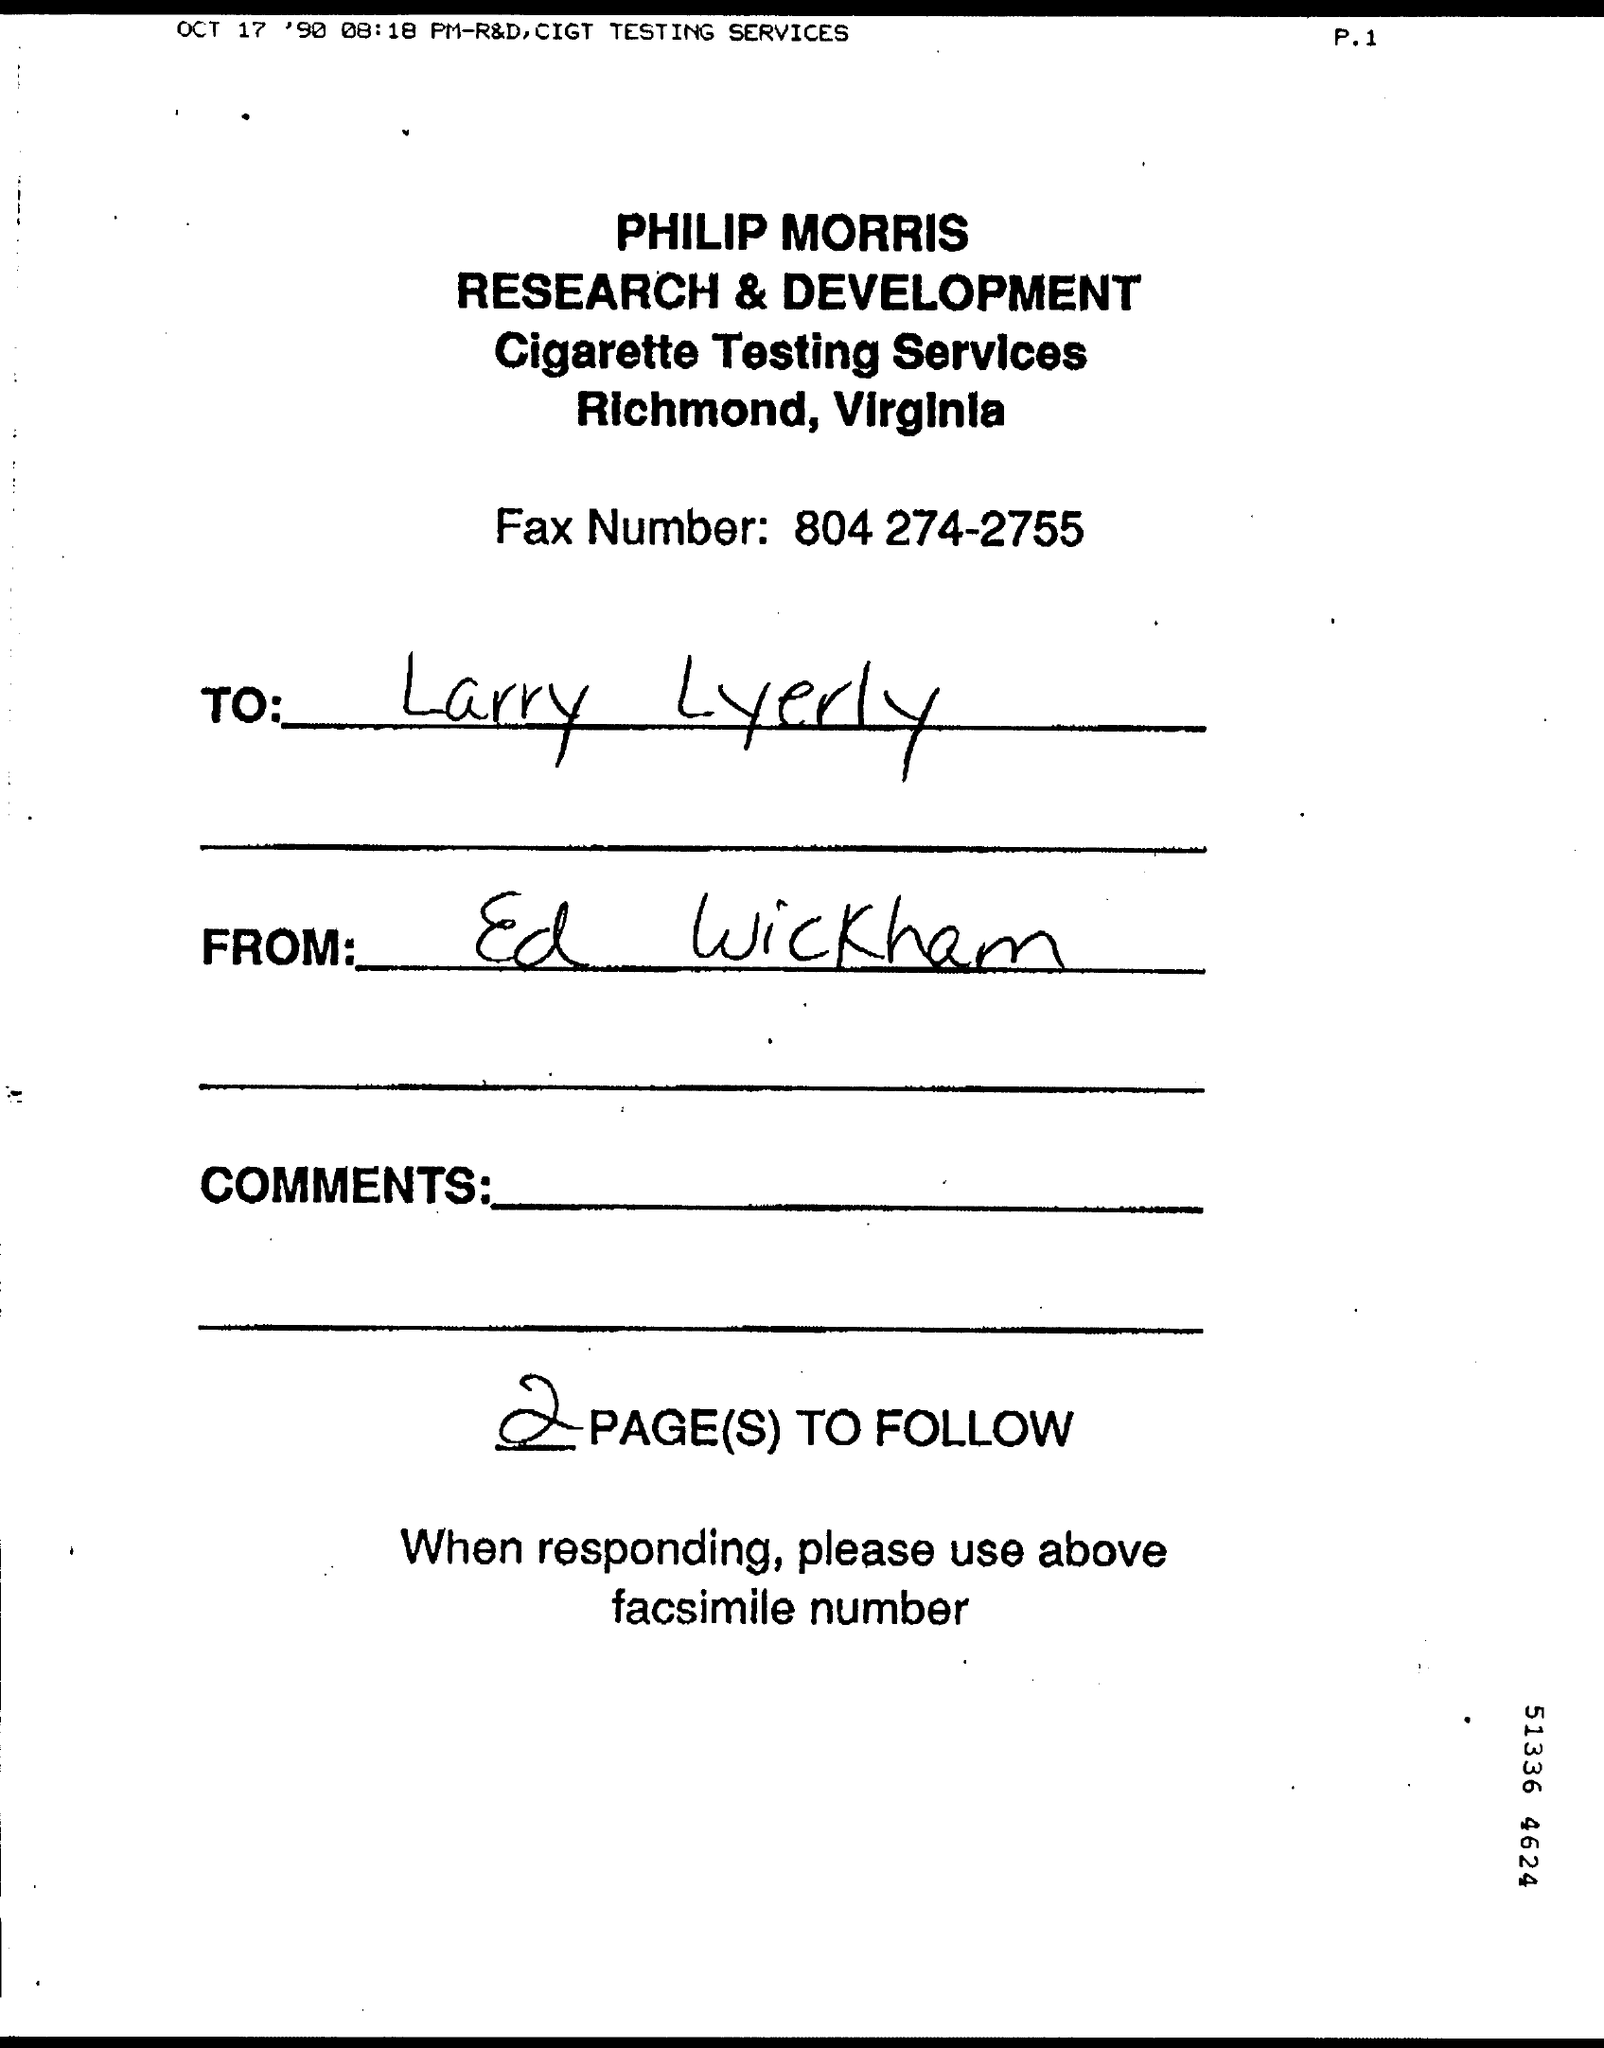What service is offered?
Provide a short and direct response. Cigarette Testing Services. What is the Fax number given?
Give a very brief answer. 804 274-2755. Who is the fax addressed to?
Your answer should be compact. Larry Lyerly. Who is the fax from?
Make the answer very short. Ed Wickham. How many pages to follow?
Your response must be concise. 2. 